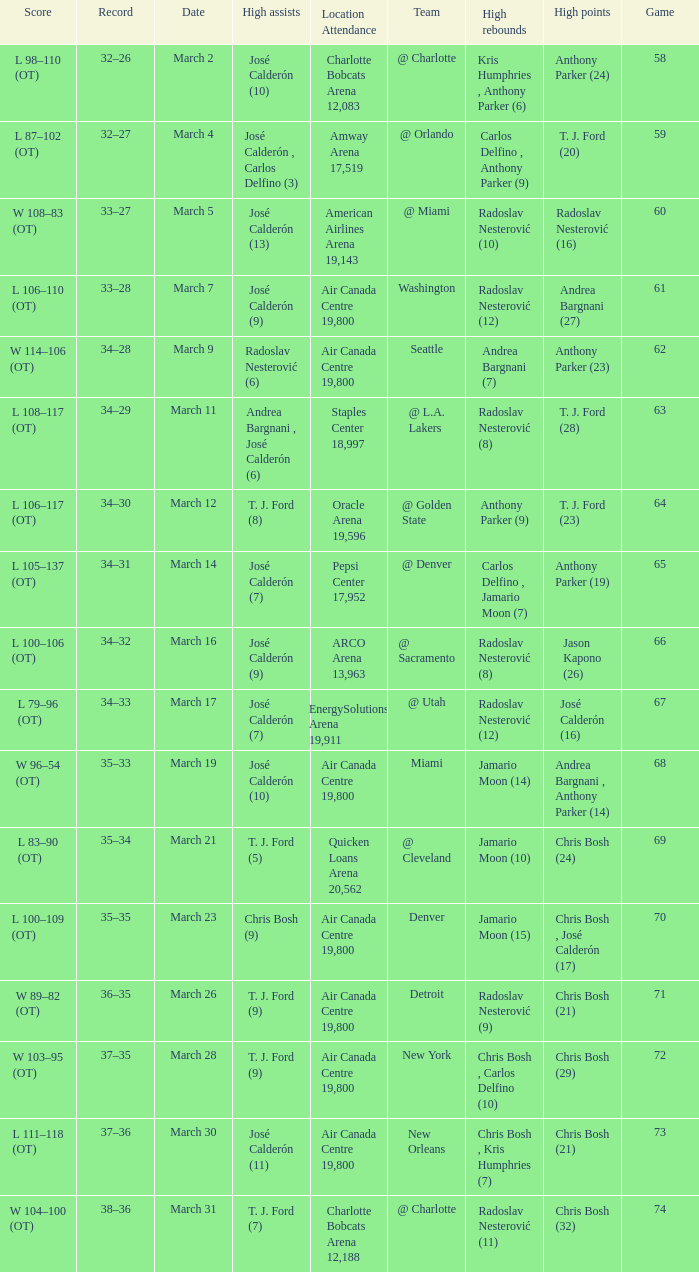What numbered game featured a High rebounds of radoslav nesterović (8), and a High assists of josé calderón (9)? 1.0. 